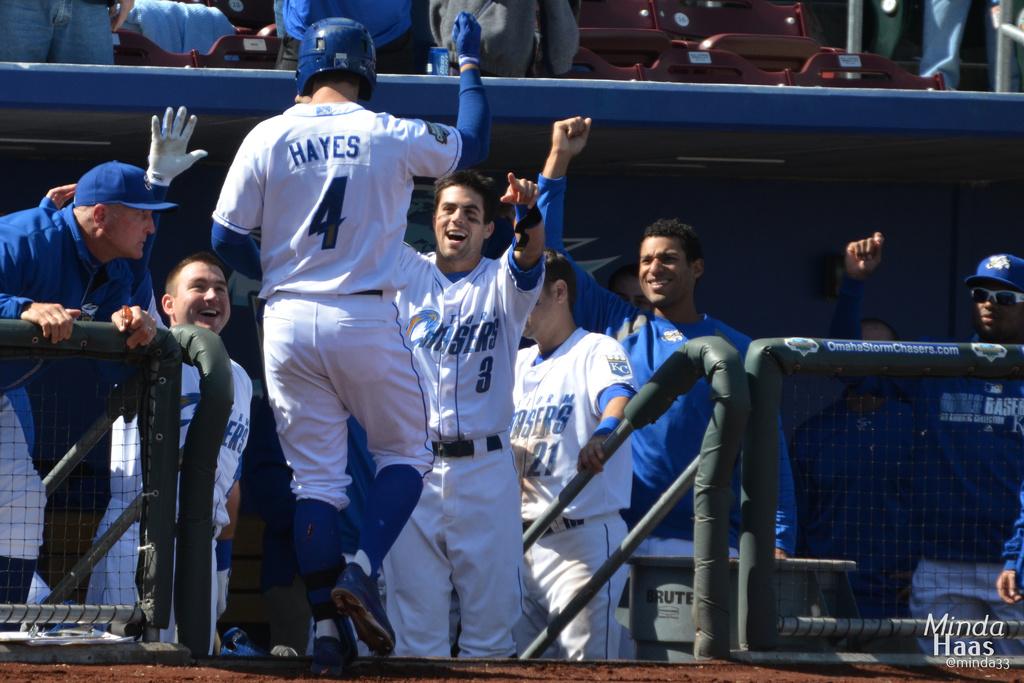What is player 4's last name?
Provide a succinct answer. Hayes. What number is hayes?
Your response must be concise. 4. 